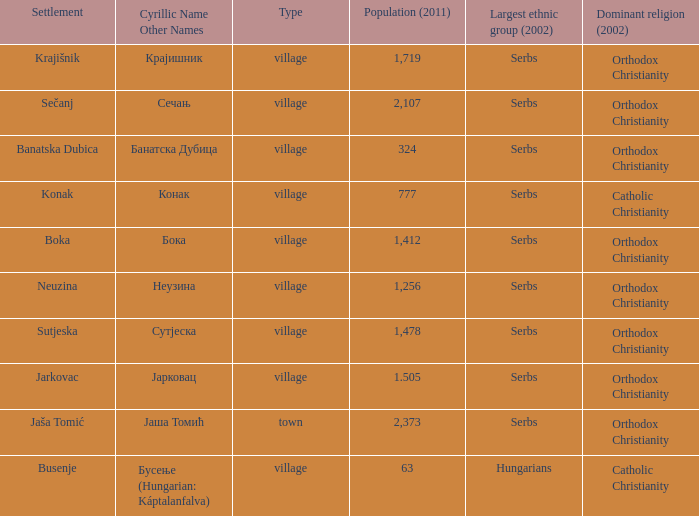The pooulation of јарковац is? 1.505. Help me parse the entirety of this table. {'header': ['Settlement', 'Cyrillic Name Other Names', 'Type', 'Population (2011)', 'Largest ethnic group (2002)', 'Dominant religion (2002)'], 'rows': [['Krajišnik', 'Крајишник', 'village', '1,719', 'Serbs', 'Orthodox Christianity'], ['Sečanj', 'Сечањ', 'village', '2,107', 'Serbs', 'Orthodox Christianity'], ['Banatska Dubica', 'Банатска Дубица', 'village', '324', 'Serbs', 'Orthodox Christianity'], ['Konak', 'Конак', 'village', '777', 'Serbs', 'Catholic Christianity'], ['Boka', 'Бока', 'village', '1,412', 'Serbs', 'Orthodox Christianity'], ['Neuzina', 'Неузина', 'village', '1,256', 'Serbs', 'Orthodox Christianity'], ['Sutjeska', 'Сутјеска', 'village', '1,478', 'Serbs', 'Orthodox Christianity'], ['Jarkovac', 'Јарковац', 'village', '1.505', 'Serbs', 'Orthodox Christianity'], ['Jaša Tomić', 'Јаша Томић', 'town', '2,373', 'Serbs', 'Orthodox Christianity'], ['Busenje', 'Бусење (Hungarian: Káptalanfalva)', 'village', '63', 'Hungarians', 'Catholic Christianity']]} 